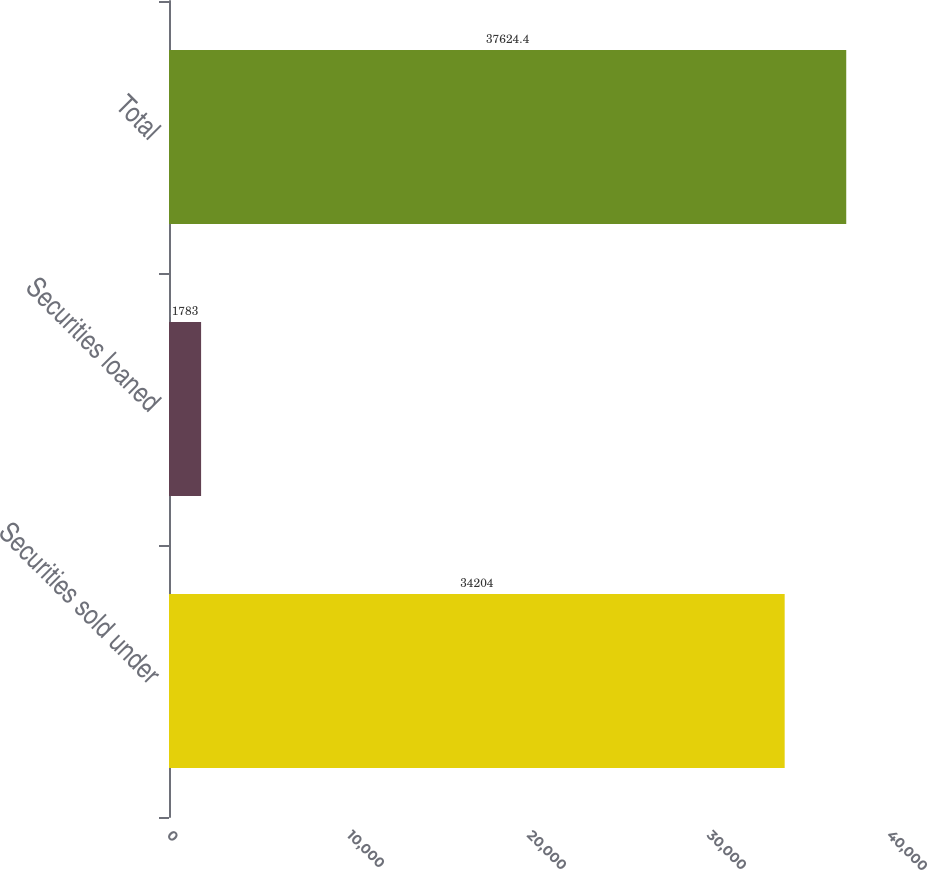<chart> <loc_0><loc_0><loc_500><loc_500><bar_chart><fcel>Securities sold under<fcel>Securities loaned<fcel>Total<nl><fcel>34204<fcel>1783<fcel>37624.4<nl></chart> 